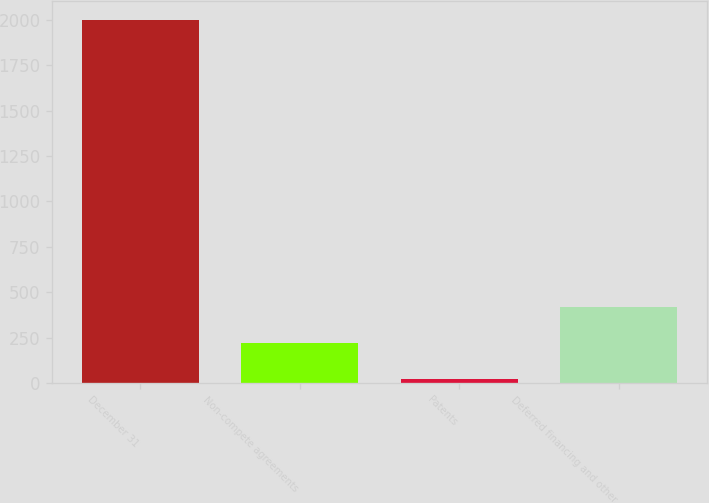Convert chart to OTSL. <chart><loc_0><loc_0><loc_500><loc_500><bar_chart><fcel>December 31<fcel>Non-compete agreements<fcel>Patents<fcel>Deferred financing and other<nl><fcel>2001<fcel>221.97<fcel>24.3<fcel>419.64<nl></chart> 